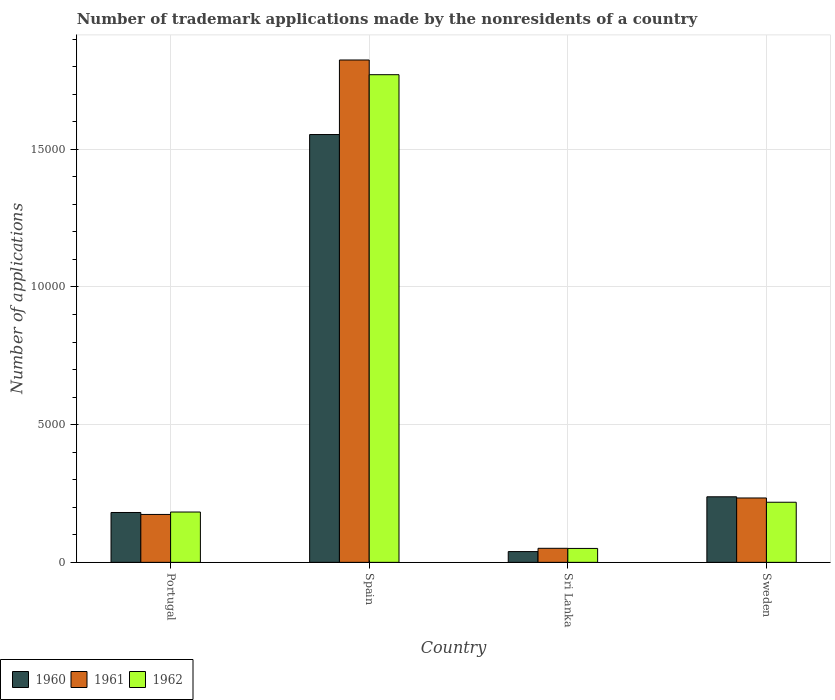How many different coloured bars are there?
Provide a short and direct response. 3. Are the number of bars per tick equal to the number of legend labels?
Offer a terse response. Yes. Are the number of bars on each tick of the X-axis equal?
Offer a terse response. Yes. How many bars are there on the 4th tick from the left?
Your answer should be very brief. 3. How many bars are there on the 4th tick from the right?
Your answer should be compact. 3. What is the label of the 3rd group of bars from the left?
Keep it short and to the point. Sri Lanka. What is the number of trademark applications made by the nonresidents in 1960 in Portugal?
Give a very brief answer. 1811. Across all countries, what is the maximum number of trademark applications made by the nonresidents in 1962?
Offer a terse response. 1.77e+04. Across all countries, what is the minimum number of trademark applications made by the nonresidents in 1962?
Make the answer very short. 506. In which country was the number of trademark applications made by the nonresidents in 1961 minimum?
Make the answer very short. Sri Lanka. What is the total number of trademark applications made by the nonresidents in 1962 in the graph?
Give a very brief answer. 2.22e+04. What is the difference between the number of trademark applications made by the nonresidents in 1961 in Spain and that in Sri Lanka?
Your response must be concise. 1.77e+04. What is the difference between the number of trademark applications made by the nonresidents in 1960 in Sri Lanka and the number of trademark applications made by the nonresidents in 1962 in Sweden?
Make the answer very short. -1792. What is the average number of trademark applications made by the nonresidents in 1961 per country?
Make the answer very short. 5708. What is the difference between the number of trademark applications made by the nonresidents of/in 1962 and number of trademark applications made by the nonresidents of/in 1960 in Sweden?
Provide a short and direct response. -198. In how many countries, is the number of trademark applications made by the nonresidents in 1960 greater than 10000?
Provide a succinct answer. 1. What is the ratio of the number of trademark applications made by the nonresidents in 1960 in Portugal to that in Sri Lanka?
Keep it short and to the point. 4.63. Is the number of trademark applications made by the nonresidents in 1961 in Spain less than that in Sri Lanka?
Offer a very short reply. No. Is the difference between the number of trademark applications made by the nonresidents in 1962 in Portugal and Sri Lanka greater than the difference between the number of trademark applications made by the nonresidents in 1960 in Portugal and Sri Lanka?
Provide a short and direct response. No. What is the difference between the highest and the second highest number of trademark applications made by the nonresidents in 1962?
Offer a terse response. -1.59e+04. What is the difference between the highest and the lowest number of trademark applications made by the nonresidents in 1961?
Your response must be concise. 1.77e+04. How many countries are there in the graph?
Offer a terse response. 4. Are the values on the major ticks of Y-axis written in scientific E-notation?
Your answer should be compact. No. Does the graph contain grids?
Provide a succinct answer. Yes. Where does the legend appear in the graph?
Give a very brief answer. Bottom left. How are the legend labels stacked?
Offer a very short reply. Horizontal. What is the title of the graph?
Provide a short and direct response. Number of trademark applications made by the nonresidents of a country. What is the label or title of the X-axis?
Give a very brief answer. Country. What is the label or title of the Y-axis?
Offer a very short reply. Number of applications. What is the Number of applications in 1960 in Portugal?
Offer a terse response. 1811. What is the Number of applications of 1961 in Portugal?
Your response must be concise. 1740. What is the Number of applications of 1962 in Portugal?
Make the answer very short. 1828. What is the Number of applications in 1960 in Spain?
Provide a short and direct response. 1.55e+04. What is the Number of applications of 1961 in Spain?
Offer a very short reply. 1.82e+04. What is the Number of applications of 1962 in Spain?
Provide a short and direct response. 1.77e+04. What is the Number of applications of 1960 in Sri Lanka?
Give a very brief answer. 391. What is the Number of applications of 1961 in Sri Lanka?
Give a very brief answer. 510. What is the Number of applications of 1962 in Sri Lanka?
Offer a terse response. 506. What is the Number of applications of 1960 in Sweden?
Provide a short and direct response. 2381. What is the Number of applications of 1961 in Sweden?
Ensure brevity in your answer.  2338. What is the Number of applications in 1962 in Sweden?
Ensure brevity in your answer.  2183. Across all countries, what is the maximum Number of applications of 1960?
Give a very brief answer. 1.55e+04. Across all countries, what is the maximum Number of applications in 1961?
Make the answer very short. 1.82e+04. Across all countries, what is the maximum Number of applications of 1962?
Your response must be concise. 1.77e+04. Across all countries, what is the minimum Number of applications in 1960?
Provide a succinct answer. 391. Across all countries, what is the minimum Number of applications in 1961?
Keep it short and to the point. 510. Across all countries, what is the minimum Number of applications of 1962?
Ensure brevity in your answer.  506. What is the total Number of applications of 1960 in the graph?
Your answer should be very brief. 2.01e+04. What is the total Number of applications of 1961 in the graph?
Ensure brevity in your answer.  2.28e+04. What is the total Number of applications of 1962 in the graph?
Offer a terse response. 2.22e+04. What is the difference between the Number of applications of 1960 in Portugal and that in Spain?
Provide a short and direct response. -1.37e+04. What is the difference between the Number of applications of 1961 in Portugal and that in Spain?
Make the answer very short. -1.65e+04. What is the difference between the Number of applications in 1962 in Portugal and that in Spain?
Provide a succinct answer. -1.59e+04. What is the difference between the Number of applications of 1960 in Portugal and that in Sri Lanka?
Provide a succinct answer. 1420. What is the difference between the Number of applications in 1961 in Portugal and that in Sri Lanka?
Offer a very short reply. 1230. What is the difference between the Number of applications of 1962 in Portugal and that in Sri Lanka?
Your answer should be compact. 1322. What is the difference between the Number of applications of 1960 in Portugal and that in Sweden?
Offer a terse response. -570. What is the difference between the Number of applications of 1961 in Portugal and that in Sweden?
Your response must be concise. -598. What is the difference between the Number of applications in 1962 in Portugal and that in Sweden?
Provide a short and direct response. -355. What is the difference between the Number of applications of 1960 in Spain and that in Sri Lanka?
Make the answer very short. 1.51e+04. What is the difference between the Number of applications of 1961 in Spain and that in Sri Lanka?
Provide a short and direct response. 1.77e+04. What is the difference between the Number of applications of 1962 in Spain and that in Sri Lanka?
Keep it short and to the point. 1.72e+04. What is the difference between the Number of applications in 1960 in Spain and that in Sweden?
Ensure brevity in your answer.  1.32e+04. What is the difference between the Number of applications in 1961 in Spain and that in Sweden?
Your answer should be very brief. 1.59e+04. What is the difference between the Number of applications in 1962 in Spain and that in Sweden?
Make the answer very short. 1.55e+04. What is the difference between the Number of applications in 1960 in Sri Lanka and that in Sweden?
Provide a succinct answer. -1990. What is the difference between the Number of applications in 1961 in Sri Lanka and that in Sweden?
Your answer should be compact. -1828. What is the difference between the Number of applications of 1962 in Sri Lanka and that in Sweden?
Provide a short and direct response. -1677. What is the difference between the Number of applications in 1960 in Portugal and the Number of applications in 1961 in Spain?
Offer a terse response. -1.64e+04. What is the difference between the Number of applications in 1960 in Portugal and the Number of applications in 1962 in Spain?
Offer a terse response. -1.59e+04. What is the difference between the Number of applications in 1961 in Portugal and the Number of applications in 1962 in Spain?
Make the answer very short. -1.60e+04. What is the difference between the Number of applications in 1960 in Portugal and the Number of applications in 1961 in Sri Lanka?
Provide a succinct answer. 1301. What is the difference between the Number of applications in 1960 in Portugal and the Number of applications in 1962 in Sri Lanka?
Provide a short and direct response. 1305. What is the difference between the Number of applications in 1961 in Portugal and the Number of applications in 1962 in Sri Lanka?
Provide a short and direct response. 1234. What is the difference between the Number of applications of 1960 in Portugal and the Number of applications of 1961 in Sweden?
Your answer should be compact. -527. What is the difference between the Number of applications in 1960 in Portugal and the Number of applications in 1962 in Sweden?
Your answer should be compact. -372. What is the difference between the Number of applications in 1961 in Portugal and the Number of applications in 1962 in Sweden?
Provide a succinct answer. -443. What is the difference between the Number of applications of 1960 in Spain and the Number of applications of 1961 in Sri Lanka?
Your answer should be very brief. 1.50e+04. What is the difference between the Number of applications in 1960 in Spain and the Number of applications in 1962 in Sri Lanka?
Keep it short and to the point. 1.50e+04. What is the difference between the Number of applications in 1961 in Spain and the Number of applications in 1962 in Sri Lanka?
Your answer should be compact. 1.77e+04. What is the difference between the Number of applications in 1960 in Spain and the Number of applications in 1961 in Sweden?
Offer a terse response. 1.32e+04. What is the difference between the Number of applications in 1960 in Spain and the Number of applications in 1962 in Sweden?
Provide a succinct answer. 1.34e+04. What is the difference between the Number of applications in 1961 in Spain and the Number of applications in 1962 in Sweden?
Your answer should be compact. 1.61e+04. What is the difference between the Number of applications of 1960 in Sri Lanka and the Number of applications of 1961 in Sweden?
Keep it short and to the point. -1947. What is the difference between the Number of applications in 1960 in Sri Lanka and the Number of applications in 1962 in Sweden?
Your answer should be compact. -1792. What is the difference between the Number of applications of 1961 in Sri Lanka and the Number of applications of 1962 in Sweden?
Your response must be concise. -1673. What is the average Number of applications of 1960 per country?
Your response must be concise. 5030. What is the average Number of applications in 1961 per country?
Your answer should be very brief. 5708. What is the average Number of applications in 1962 per country?
Give a very brief answer. 5556.75. What is the difference between the Number of applications in 1960 and Number of applications in 1961 in Portugal?
Your answer should be very brief. 71. What is the difference between the Number of applications of 1961 and Number of applications of 1962 in Portugal?
Offer a terse response. -88. What is the difference between the Number of applications in 1960 and Number of applications in 1961 in Spain?
Offer a terse response. -2707. What is the difference between the Number of applications of 1960 and Number of applications of 1962 in Spain?
Your response must be concise. -2173. What is the difference between the Number of applications in 1961 and Number of applications in 1962 in Spain?
Your answer should be compact. 534. What is the difference between the Number of applications of 1960 and Number of applications of 1961 in Sri Lanka?
Offer a terse response. -119. What is the difference between the Number of applications of 1960 and Number of applications of 1962 in Sri Lanka?
Provide a short and direct response. -115. What is the difference between the Number of applications in 1961 and Number of applications in 1962 in Sri Lanka?
Offer a terse response. 4. What is the difference between the Number of applications of 1960 and Number of applications of 1962 in Sweden?
Make the answer very short. 198. What is the difference between the Number of applications of 1961 and Number of applications of 1962 in Sweden?
Keep it short and to the point. 155. What is the ratio of the Number of applications of 1960 in Portugal to that in Spain?
Your answer should be very brief. 0.12. What is the ratio of the Number of applications of 1961 in Portugal to that in Spain?
Your answer should be compact. 0.1. What is the ratio of the Number of applications in 1962 in Portugal to that in Spain?
Ensure brevity in your answer.  0.1. What is the ratio of the Number of applications of 1960 in Portugal to that in Sri Lanka?
Offer a terse response. 4.63. What is the ratio of the Number of applications of 1961 in Portugal to that in Sri Lanka?
Offer a very short reply. 3.41. What is the ratio of the Number of applications of 1962 in Portugal to that in Sri Lanka?
Offer a very short reply. 3.61. What is the ratio of the Number of applications of 1960 in Portugal to that in Sweden?
Offer a terse response. 0.76. What is the ratio of the Number of applications in 1961 in Portugal to that in Sweden?
Offer a very short reply. 0.74. What is the ratio of the Number of applications in 1962 in Portugal to that in Sweden?
Provide a short and direct response. 0.84. What is the ratio of the Number of applications in 1960 in Spain to that in Sri Lanka?
Keep it short and to the point. 39.74. What is the ratio of the Number of applications in 1961 in Spain to that in Sri Lanka?
Give a very brief answer. 35.77. What is the ratio of the Number of applications of 1962 in Spain to that in Sri Lanka?
Give a very brief answer. 35. What is the ratio of the Number of applications of 1960 in Spain to that in Sweden?
Your response must be concise. 6.53. What is the ratio of the Number of applications of 1961 in Spain to that in Sweden?
Provide a short and direct response. 7.8. What is the ratio of the Number of applications in 1962 in Spain to that in Sweden?
Keep it short and to the point. 8.11. What is the ratio of the Number of applications in 1960 in Sri Lanka to that in Sweden?
Give a very brief answer. 0.16. What is the ratio of the Number of applications of 1961 in Sri Lanka to that in Sweden?
Your response must be concise. 0.22. What is the ratio of the Number of applications in 1962 in Sri Lanka to that in Sweden?
Provide a short and direct response. 0.23. What is the difference between the highest and the second highest Number of applications in 1960?
Keep it short and to the point. 1.32e+04. What is the difference between the highest and the second highest Number of applications in 1961?
Offer a very short reply. 1.59e+04. What is the difference between the highest and the second highest Number of applications in 1962?
Your answer should be compact. 1.55e+04. What is the difference between the highest and the lowest Number of applications in 1960?
Your answer should be compact. 1.51e+04. What is the difference between the highest and the lowest Number of applications in 1961?
Make the answer very short. 1.77e+04. What is the difference between the highest and the lowest Number of applications in 1962?
Offer a very short reply. 1.72e+04. 